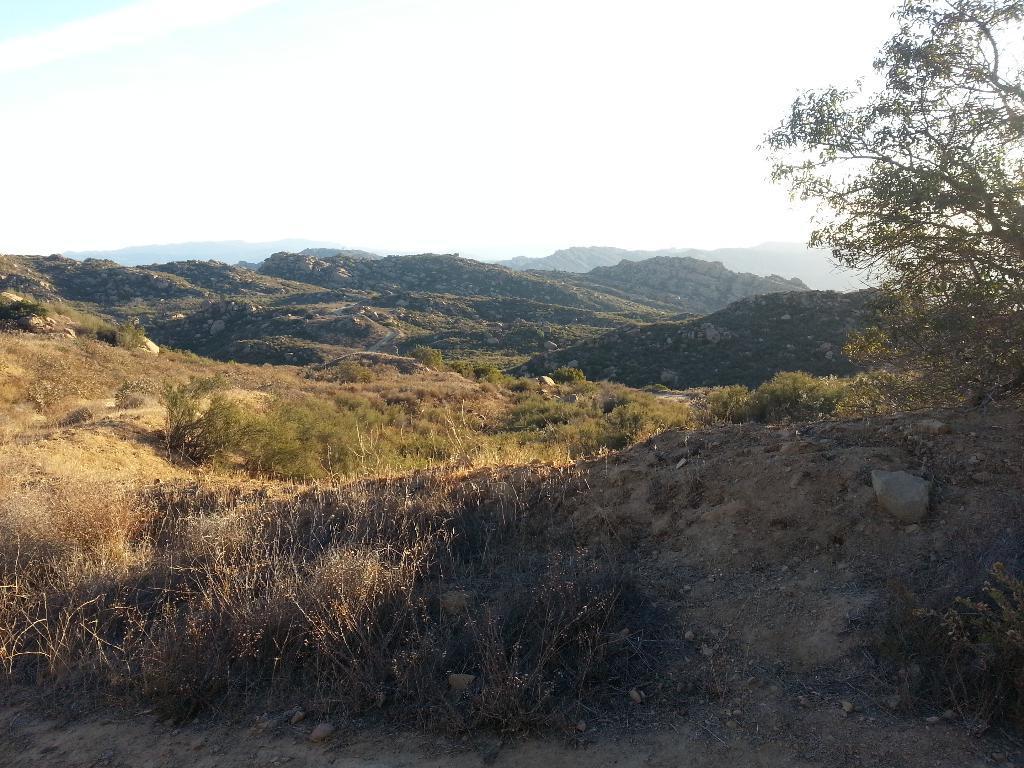Describe this image in one or two sentences. In this picture we can see there are plants, a tree, hills and the sky. 